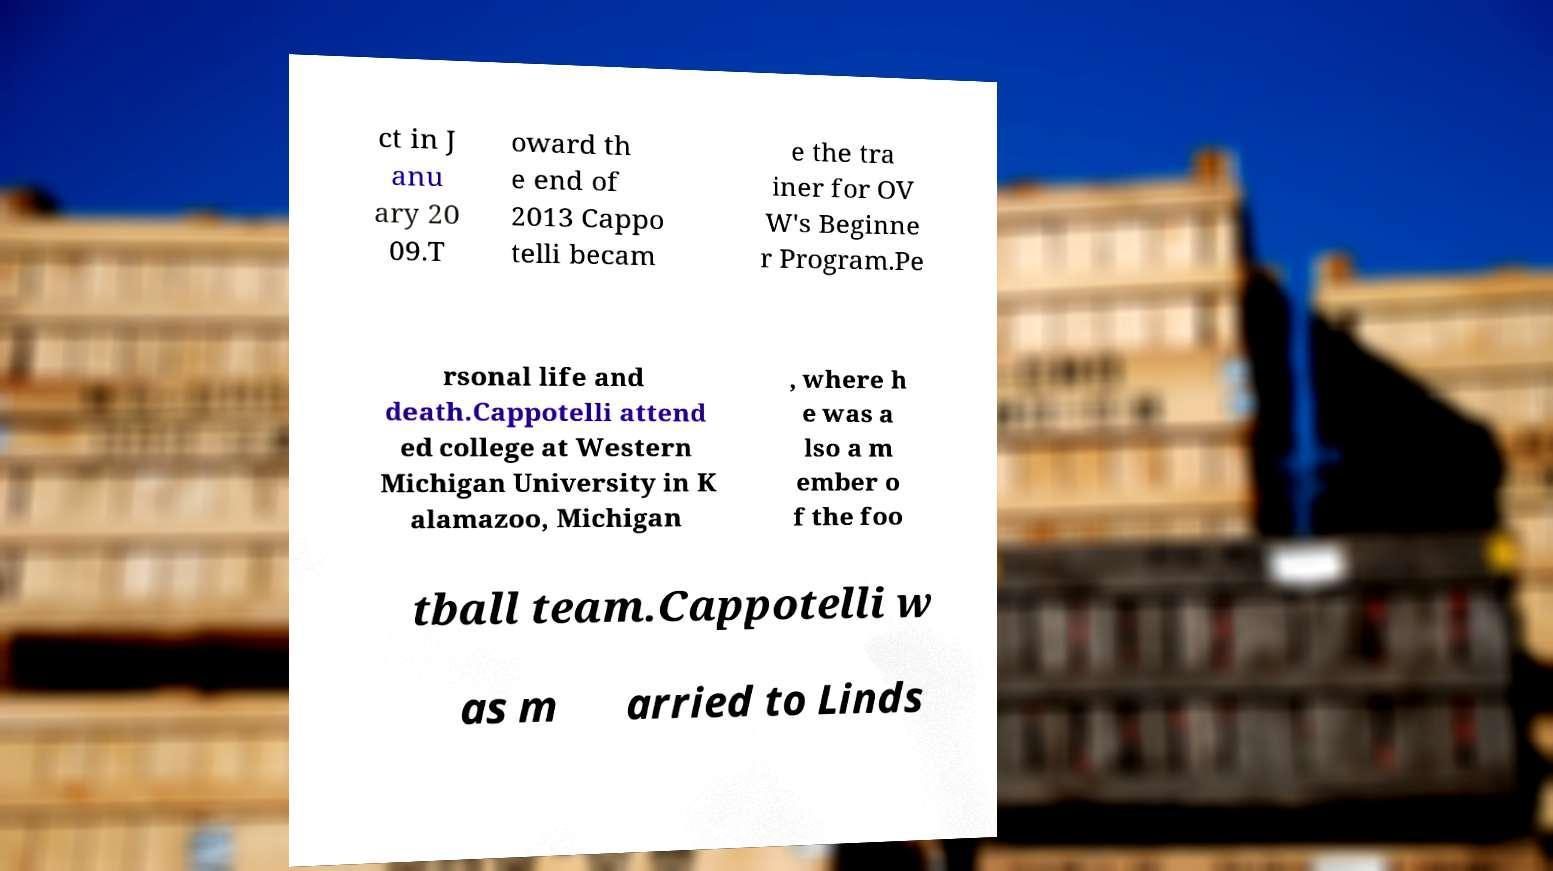I need the written content from this picture converted into text. Can you do that? ct in J anu ary 20 09.T oward th e end of 2013 Cappo telli becam e the tra iner for OV W's Beginne r Program.Pe rsonal life and death.Cappotelli attend ed college at Western Michigan University in K alamazoo, Michigan , where h e was a lso a m ember o f the foo tball team.Cappotelli w as m arried to Linds 